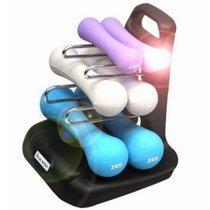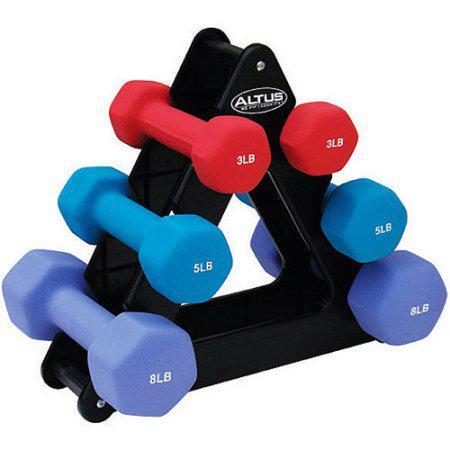The first image is the image on the left, the second image is the image on the right. Evaluate the accuracy of this statement regarding the images: "A lavender weight is at the top of the holder in one of the images.". Is it true? Answer yes or no. Yes. The first image is the image on the left, the second image is the image on the right. Examine the images to the left and right. Is the description "In each image, three pairs of dumbbells, each a different color, at stacked on a triangular shaped rack with a pink pair in the uppermost position." accurate? Answer yes or no. No. 